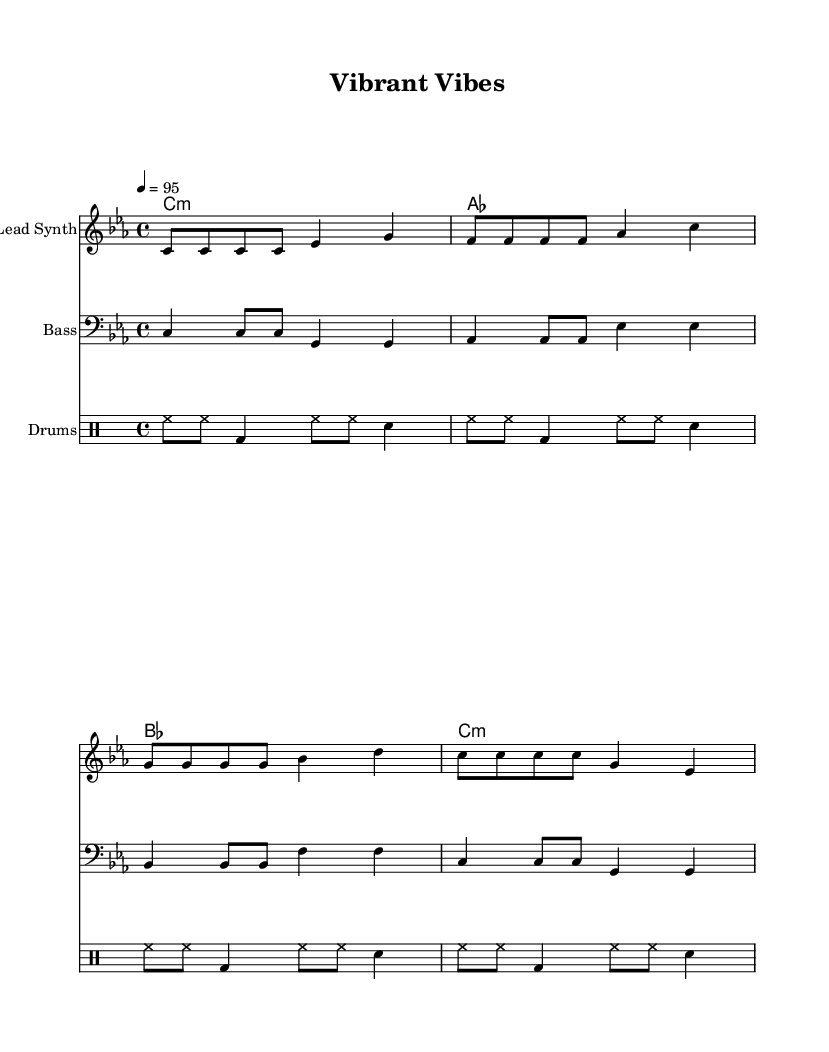What is the key signature of this music? The key signature is C minor, indicated by the presence of three flats (B♭, E♭, A♭) at the beginning of the staff.
Answer: C minor What is the time signature of this music? The time signature is 4/4, which is shown at the beginning of the score, indicating that there are four beats per measure and the quarter note gets one beat.
Answer: 4/4 What is the tempo marking of this music? The tempo marking is 95 beats per minute, indicated by the "4 = 95" notation which guides the performer on how fast to play the piece.
Answer: 95 How many measures are in the lead synth part? The lead synth part contains four measures, as counted by the vertical bar lines which indicate measure separations.
Answer: 4 Which instruments are included in this score? The instruments included are Lead Synth, Bass, and Drums, as each part is specified at the beginning of their respective staves.
Answer: Lead Synth, Bass, Drums What type of chords are used in this piece? The chords used are minor and major, specifically C minor, A♭ major, B♭ major, and C minor again, as evidenced by the chord symbols above the staff.
Answer: C minor, A♭, B♭ 